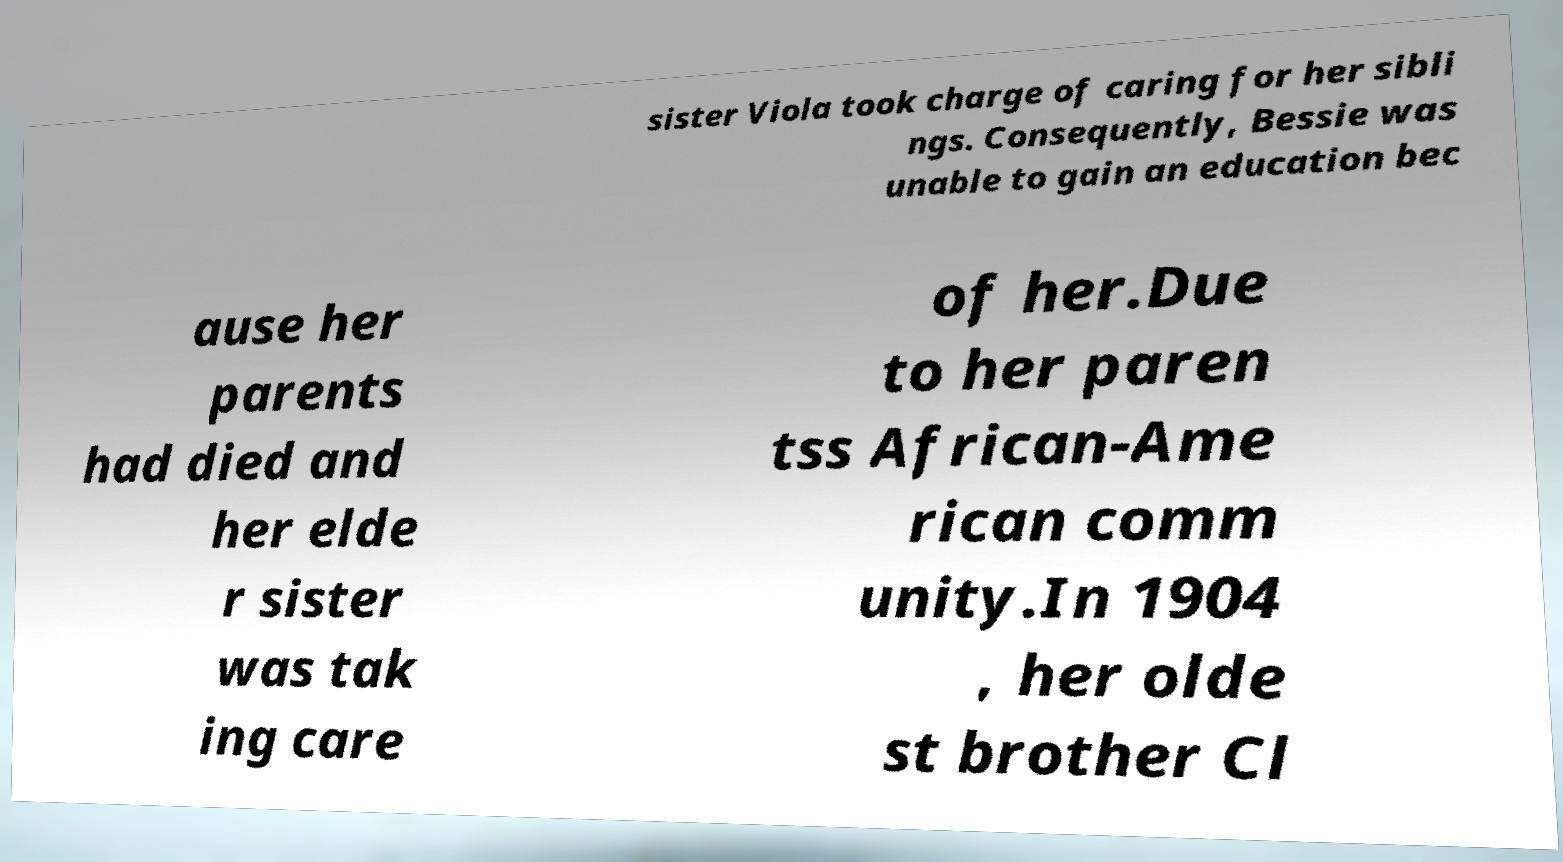Can you read and provide the text displayed in the image?This photo seems to have some interesting text. Can you extract and type it out for me? sister Viola took charge of caring for her sibli ngs. Consequently, Bessie was unable to gain an education bec ause her parents had died and her elde r sister was tak ing care of her.Due to her paren tss African-Ame rican comm unity.In 1904 , her olde st brother Cl 